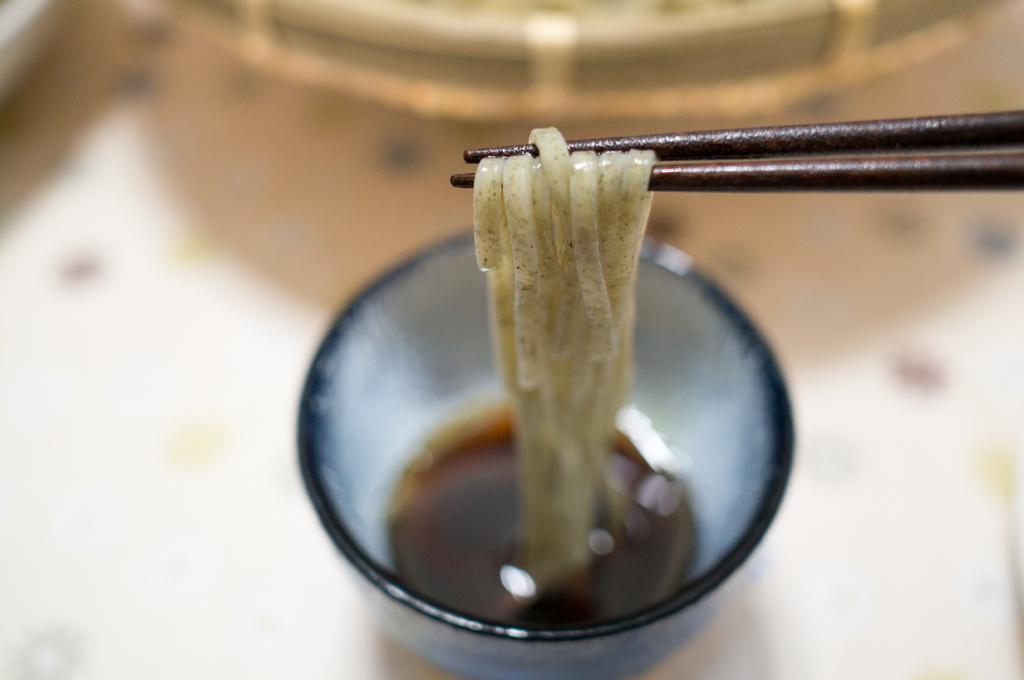What is in the glass that is visible in the image? There is no information about what is in the glass, only that there is a glass present. Besides the glass, what other items can be seen in the image? There are chopsticks and noodles visible in the image. How are the chopsticks positioned in the image? The provided facts do not specify the position of the chopsticks. What is the background of the glass like? The background of the glass is blurred. How much debt is the key associated with in the image? There is no key, debt, or any financial concept mentioned in the image. 